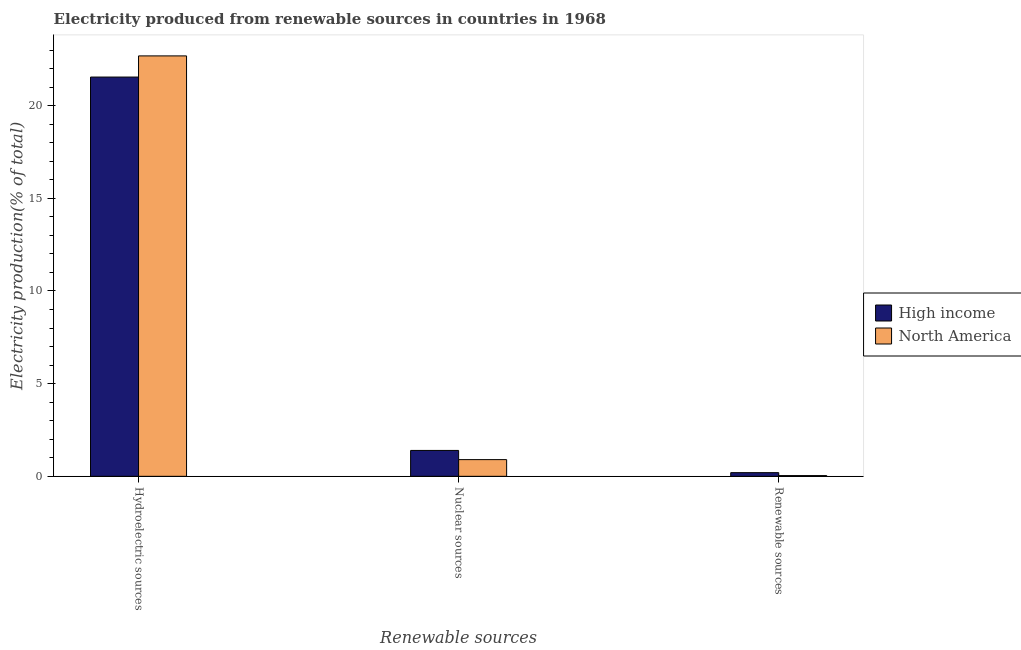How many different coloured bars are there?
Make the answer very short. 2. How many groups of bars are there?
Ensure brevity in your answer.  3. Are the number of bars per tick equal to the number of legend labels?
Provide a short and direct response. Yes. Are the number of bars on each tick of the X-axis equal?
Make the answer very short. Yes. What is the label of the 2nd group of bars from the left?
Your response must be concise. Nuclear sources. What is the percentage of electricity produced by hydroelectric sources in High income?
Ensure brevity in your answer.  21.54. Across all countries, what is the maximum percentage of electricity produced by hydroelectric sources?
Your answer should be very brief. 22.69. Across all countries, what is the minimum percentage of electricity produced by renewable sources?
Your response must be concise. 0.04. In which country was the percentage of electricity produced by renewable sources minimum?
Offer a very short reply. North America. What is the total percentage of electricity produced by renewable sources in the graph?
Your answer should be compact. 0.24. What is the difference between the percentage of electricity produced by renewable sources in North America and that in High income?
Your answer should be very brief. -0.16. What is the difference between the percentage of electricity produced by hydroelectric sources in North America and the percentage of electricity produced by nuclear sources in High income?
Your answer should be compact. 21.29. What is the average percentage of electricity produced by hydroelectric sources per country?
Offer a very short reply. 22.11. What is the difference between the percentage of electricity produced by renewable sources and percentage of electricity produced by hydroelectric sources in North America?
Offer a terse response. -22.65. In how many countries, is the percentage of electricity produced by hydroelectric sources greater than 13 %?
Your response must be concise. 2. What is the ratio of the percentage of electricity produced by hydroelectric sources in North America to that in High income?
Offer a very short reply. 1.05. What is the difference between the highest and the second highest percentage of electricity produced by renewable sources?
Keep it short and to the point. 0.16. What is the difference between the highest and the lowest percentage of electricity produced by nuclear sources?
Your answer should be very brief. 0.5. In how many countries, is the percentage of electricity produced by hydroelectric sources greater than the average percentage of electricity produced by hydroelectric sources taken over all countries?
Your answer should be compact. 1. What does the 2nd bar from the left in Hydroelectric sources represents?
Keep it short and to the point. North America. What does the 1st bar from the right in Hydroelectric sources represents?
Your answer should be compact. North America. How many countries are there in the graph?
Ensure brevity in your answer.  2. Are the values on the major ticks of Y-axis written in scientific E-notation?
Keep it short and to the point. No. Does the graph contain grids?
Offer a very short reply. No. How many legend labels are there?
Keep it short and to the point. 2. What is the title of the graph?
Your answer should be very brief. Electricity produced from renewable sources in countries in 1968. What is the label or title of the X-axis?
Make the answer very short. Renewable sources. What is the label or title of the Y-axis?
Offer a terse response. Electricity production(% of total). What is the Electricity production(% of total) of High income in Hydroelectric sources?
Ensure brevity in your answer.  21.54. What is the Electricity production(% of total) in North America in Hydroelectric sources?
Provide a succinct answer. 22.69. What is the Electricity production(% of total) of High income in Nuclear sources?
Ensure brevity in your answer.  1.4. What is the Electricity production(% of total) of North America in Nuclear sources?
Give a very brief answer. 0.9. What is the Electricity production(% of total) of High income in Renewable sources?
Keep it short and to the point. 0.2. What is the Electricity production(% of total) in North America in Renewable sources?
Your response must be concise. 0.04. Across all Renewable sources, what is the maximum Electricity production(% of total) in High income?
Make the answer very short. 21.54. Across all Renewable sources, what is the maximum Electricity production(% of total) of North America?
Your answer should be very brief. 22.69. Across all Renewable sources, what is the minimum Electricity production(% of total) in High income?
Keep it short and to the point. 0.2. Across all Renewable sources, what is the minimum Electricity production(% of total) in North America?
Provide a short and direct response. 0.04. What is the total Electricity production(% of total) in High income in the graph?
Provide a short and direct response. 23.14. What is the total Electricity production(% of total) in North America in the graph?
Provide a short and direct response. 23.63. What is the difference between the Electricity production(% of total) of High income in Hydroelectric sources and that in Nuclear sources?
Keep it short and to the point. 20.15. What is the difference between the Electricity production(% of total) in North America in Hydroelectric sources and that in Nuclear sources?
Ensure brevity in your answer.  21.78. What is the difference between the Electricity production(% of total) in High income in Hydroelectric sources and that in Renewable sources?
Provide a succinct answer. 21.35. What is the difference between the Electricity production(% of total) in North America in Hydroelectric sources and that in Renewable sources?
Your answer should be very brief. 22.65. What is the difference between the Electricity production(% of total) in High income in Nuclear sources and that in Renewable sources?
Provide a succinct answer. 1.2. What is the difference between the Electricity production(% of total) of North America in Nuclear sources and that in Renewable sources?
Your answer should be compact. 0.86. What is the difference between the Electricity production(% of total) in High income in Hydroelectric sources and the Electricity production(% of total) in North America in Nuclear sources?
Ensure brevity in your answer.  20.64. What is the difference between the Electricity production(% of total) of High income in Hydroelectric sources and the Electricity production(% of total) of North America in Renewable sources?
Provide a short and direct response. 21.5. What is the difference between the Electricity production(% of total) in High income in Nuclear sources and the Electricity production(% of total) in North America in Renewable sources?
Offer a terse response. 1.36. What is the average Electricity production(% of total) in High income per Renewable sources?
Your response must be concise. 7.71. What is the average Electricity production(% of total) of North America per Renewable sources?
Offer a very short reply. 7.88. What is the difference between the Electricity production(% of total) of High income and Electricity production(% of total) of North America in Hydroelectric sources?
Provide a succinct answer. -1.14. What is the difference between the Electricity production(% of total) of High income and Electricity production(% of total) of North America in Nuclear sources?
Provide a short and direct response. 0.5. What is the difference between the Electricity production(% of total) of High income and Electricity production(% of total) of North America in Renewable sources?
Your response must be concise. 0.16. What is the ratio of the Electricity production(% of total) in High income in Hydroelectric sources to that in Nuclear sources?
Give a very brief answer. 15.42. What is the ratio of the Electricity production(% of total) of North America in Hydroelectric sources to that in Nuclear sources?
Your response must be concise. 25.16. What is the ratio of the Electricity production(% of total) of High income in Hydroelectric sources to that in Renewable sources?
Provide a succinct answer. 108.87. What is the ratio of the Electricity production(% of total) of North America in Hydroelectric sources to that in Renewable sources?
Make the answer very short. 573. What is the ratio of the Electricity production(% of total) of High income in Nuclear sources to that in Renewable sources?
Ensure brevity in your answer.  7.06. What is the ratio of the Electricity production(% of total) of North America in Nuclear sources to that in Renewable sources?
Your response must be concise. 22.77. What is the difference between the highest and the second highest Electricity production(% of total) of High income?
Offer a very short reply. 20.15. What is the difference between the highest and the second highest Electricity production(% of total) of North America?
Keep it short and to the point. 21.78. What is the difference between the highest and the lowest Electricity production(% of total) of High income?
Your answer should be compact. 21.35. What is the difference between the highest and the lowest Electricity production(% of total) in North America?
Offer a very short reply. 22.65. 